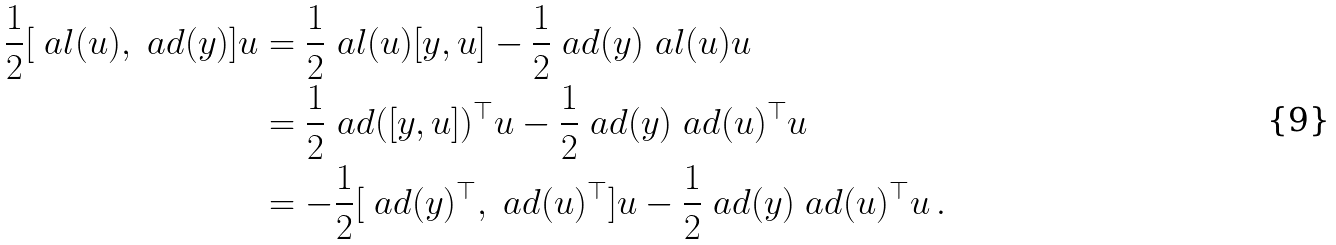Convert formula to latex. <formula><loc_0><loc_0><loc_500><loc_500>\frac { 1 } { 2 } [ \ a l ( u ) , \ a d ( y ) ] u & = \frac { 1 } { 2 } \ a l ( u ) [ y , u ] - \frac { 1 } { 2 } \ a d ( y ) \ a l ( u ) u \\ & = \frac { 1 } { 2 } \ a d ( [ y , u ] ) ^ { \top } u - \frac { 1 } { 2 } \ a d ( y ) \ a d ( u ) ^ { \top } u \\ & = - \frac { 1 } { 2 } [ \ a d ( y ) ^ { \top } , \ a d ( u ) ^ { \top } ] u - \frac { 1 } { 2 } \ a d ( y ) \ a d ( u ) ^ { \top } u \, .</formula> 